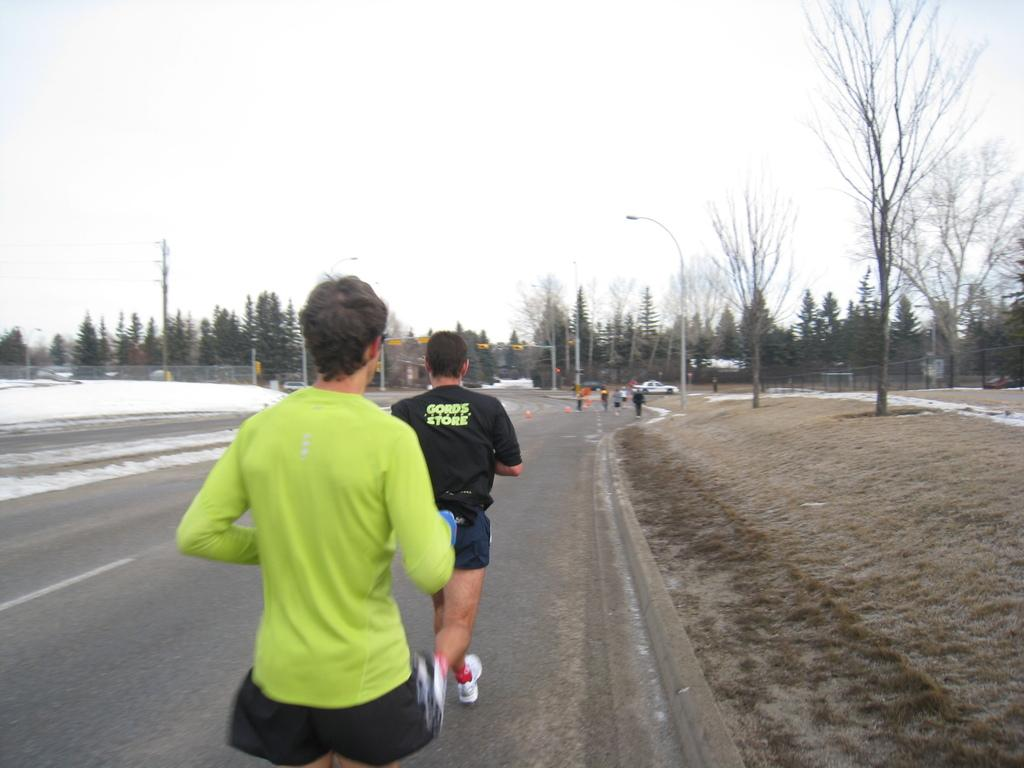What are the people in the image doing? The people in the image are walking on the road. What can be seen in the background of the image? There are trees visible in the image. What is visible above the trees and people? The sky is visible in the image. How many bulbs are hanging from the trees in the image? There are no bulbs visible in the image; only trees, people, and the sky are present. 